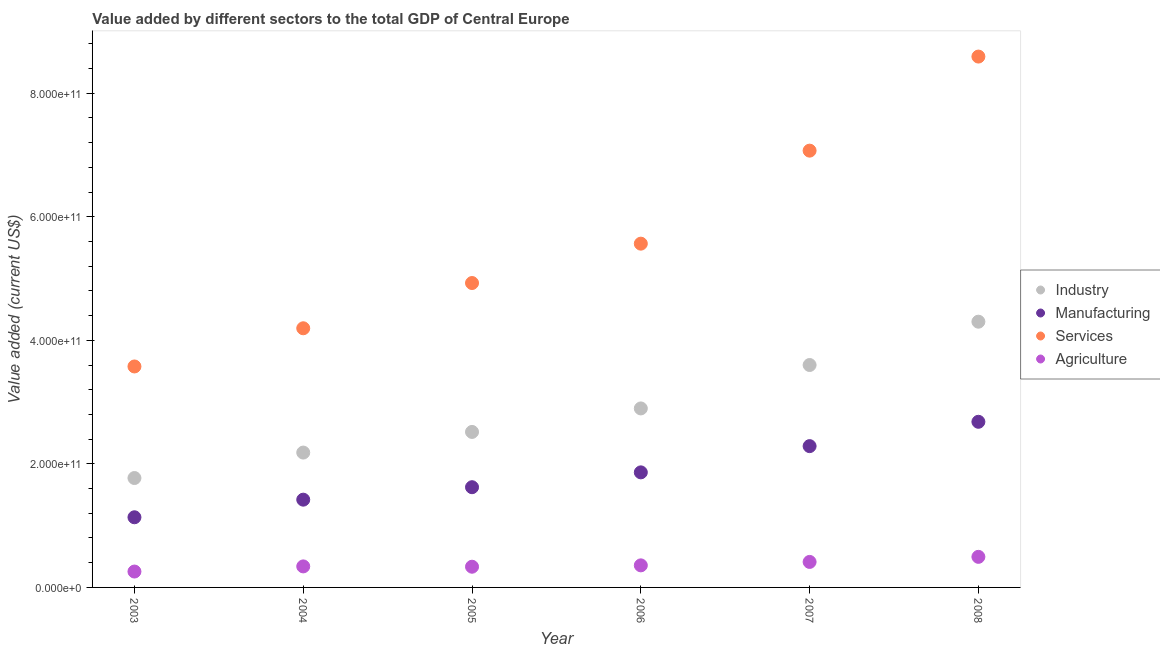What is the value added by manufacturing sector in 2005?
Ensure brevity in your answer.  1.62e+11. Across all years, what is the maximum value added by manufacturing sector?
Ensure brevity in your answer.  2.68e+11. Across all years, what is the minimum value added by manufacturing sector?
Give a very brief answer. 1.14e+11. In which year was the value added by manufacturing sector maximum?
Give a very brief answer. 2008. What is the total value added by manufacturing sector in the graph?
Provide a short and direct response. 1.10e+12. What is the difference between the value added by services sector in 2004 and that in 2006?
Provide a short and direct response. -1.37e+11. What is the difference between the value added by industrial sector in 2007 and the value added by services sector in 2008?
Keep it short and to the point. -4.99e+11. What is the average value added by agricultural sector per year?
Offer a very short reply. 3.66e+1. In the year 2006, what is the difference between the value added by manufacturing sector and value added by services sector?
Make the answer very short. -3.70e+11. What is the ratio of the value added by agricultural sector in 2006 to that in 2007?
Your response must be concise. 0.87. Is the value added by manufacturing sector in 2006 less than that in 2008?
Give a very brief answer. Yes. Is the difference between the value added by services sector in 2006 and 2008 greater than the difference between the value added by manufacturing sector in 2006 and 2008?
Your response must be concise. No. What is the difference between the highest and the second highest value added by industrial sector?
Make the answer very short. 7.01e+1. What is the difference between the highest and the lowest value added by agricultural sector?
Provide a short and direct response. 2.38e+1. Is it the case that in every year, the sum of the value added by industrial sector and value added by manufacturing sector is greater than the value added by services sector?
Ensure brevity in your answer.  No. Does the value added by services sector monotonically increase over the years?
Your answer should be very brief. Yes. Is the value added by industrial sector strictly greater than the value added by manufacturing sector over the years?
Your answer should be very brief. Yes. Is the value added by industrial sector strictly less than the value added by manufacturing sector over the years?
Provide a succinct answer. No. How many years are there in the graph?
Your answer should be compact. 6. What is the difference between two consecutive major ticks on the Y-axis?
Provide a short and direct response. 2.00e+11. Are the values on the major ticks of Y-axis written in scientific E-notation?
Make the answer very short. Yes. Does the graph contain any zero values?
Ensure brevity in your answer.  No. Does the graph contain grids?
Offer a very short reply. No. How are the legend labels stacked?
Your response must be concise. Vertical. What is the title of the graph?
Provide a succinct answer. Value added by different sectors to the total GDP of Central Europe. What is the label or title of the X-axis?
Keep it short and to the point. Year. What is the label or title of the Y-axis?
Your response must be concise. Value added (current US$). What is the Value added (current US$) of Industry in 2003?
Offer a very short reply. 1.77e+11. What is the Value added (current US$) in Manufacturing in 2003?
Your answer should be compact. 1.14e+11. What is the Value added (current US$) in Services in 2003?
Your answer should be very brief. 3.58e+11. What is the Value added (current US$) of Agriculture in 2003?
Ensure brevity in your answer.  2.57e+1. What is the Value added (current US$) in Industry in 2004?
Offer a very short reply. 2.18e+11. What is the Value added (current US$) in Manufacturing in 2004?
Provide a short and direct response. 1.42e+11. What is the Value added (current US$) of Services in 2004?
Your answer should be very brief. 4.19e+11. What is the Value added (current US$) of Agriculture in 2004?
Provide a succinct answer. 3.40e+1. What is the Value added (current US$) in Industry in 2005?
Give a very brief answer. 2.52e+11. What is the Value added (current US$) in Manufacturing in 2005?
Offer a terse response. 1.62e+11. What is the Value added (current US$) in Services in 2005?
Provide a succinct answer. 4.93e+11. What is the Value added (current US$) in Agriculture in 2005?
Your answer should be compact. 3.35e+1. What is the Value added (current US$) of Industry in 2006?
Make the answer very short. 2.90e+11. What is the Value added (current US$) in Manufacturing in 2006?
Keep it short and to the point. 1.86e+11. What is the Value added (current US$) in Services in 2006?
Offer a very short reply. 5.56e+11. What is the Value added (current US$) of Agriculture in 2006?
Provide a succinct answer. 3.57e+1. What is the Value added (current US$) of Industry in 2007?
Your answer should be compact. 3.60e+11. What is the Value added (current US$) of Manufacturing in 2007?
Offer a very short reply. 2.29e+11. What is the Value added (current US$) of Services in 2007?
Provide a succinct answer. 7.07e+11. What is the Value added (current US$) in Agriculture in 2007?
Offer a terse response. 4.13e+1. What is the Value added (current US$) in Industry in 2008?
Your answer should be compact. 4.30e+11. What is the Value added (current US$) of Manufacturing in 2008?
Make the answer very short. 2.68e+11. What is the Value added (current US$) in Services in 2008?
Your answer should be very brief. 8.59e+11. What is the Value added (current US$) of Agriculture in 2008?
Ensure brevity in your answer.  4.95e+1. Across all years, what is the maximum Value added (current US$) of Industry?
Your answer should be very brief. 4.30e+11. Across all years, what is the maximum Value added (current US$) in Manufacturing?
Make the answer very short. 2.68e+11. Across all years, what is the maximum Value added (current US$) of Services?
Offer a very short reply. 8.59e+11. Across all years, what is the maximum Value added (current US$) in Agriculture?
Ensure brevity in your answer.  4.95e+1. Across all years, what is the minimum Value added (current US$) in Industry?
Make the answer very short. 1.77e+11. Across all years, what is the minimum Value added (current US$) of Manufacturing?
Your answer should be very brief. 1.14e+11. Across all years, what is the minimum Value added (current US$) in Services?
Keep it short and to the point. 3.58e+11. Across all years, what is the minimum Value added (current US$) of Agriculture?
Your answer should be compact. 2.57e+1. What is the total Value added (current US$) in Industry in the graph?
Give a very brief answer. 1.73e+12. What is the total Value added (current US$) in Manufacturing in the graph?
Your response must be concise. 1.10e+12. What is the total Value added (current US$) of Services in the graph?
Offer a terse response. 3.39e+12. What is the total Value added (current US$) in Agriculture in the graph?
Provide a succinct answer. 2.20e+11. What is the difference between the Value added (current US$) in Industry in 2003 and that in 2004?
Your response must be concise. -4.12e+1. What is the difference between the Value added (current US$) of Manufacturing in 2003 and that in 2004?
Your answer should be very brief. -2.85e+1. What is the difference between the Value added (current US$) in Services in 2003 and that in 2004?
Provide a succinct answer. -6.18e+1. What is the difference between the Value added (current US$) of Agriculture in 2003 and that in 2004?
Provide a short and direct response. -8.32e+09. What is the difference between the Value added (current US$) in Industry in 2003 and that in 2005?
Your answer should be compact. -7.46e+1. What is the difference between the Value added (current US$) of Manufacturing in 2003 and that in 2005?
Offer a terse response. -4.87e+1. What is the difference between the Value added (current US$) in Services in 2003 and that in 2005?
Make the answer very short. -1.35e+11. What is the difference between the Value added (current US$) in Agriculture in 2003 and that in 2005?
Provide a succinct answer. -7.81e+09. What is the difference between the Value added (current US$) in Industry in 2003 and that in 2006?
Your answer should be compact. -1.13e+11. What is the difference between the Value added (current US$) of Manufacturing in 2003 and that in 2006?
Give a very brief answer. -7.27e+1. What is the difference between the Value added (current US$) of Services in 2003 and that in 2006?
Keep it short and to the point. -1.99e+11. What is the difference between the Value added (current US$) of Agriculture in 2003 and that in 2006?
Give a very brief answer. -1.00e+1. What is the difference between the Value added (current US$) in Industry in 2003 and that in 2007?
Make the answer very short. -1.83e+11. What is the difference between the Value added (current US$) of Manufacturing in 2003 and that in 2007?
Keep it short and to the point. -1.15e+11. What is the difference between the Value added (current US$) in Services in 2003 and that in 2007?
Offer a terse response. -3.49e+11. What is the difference between the Value added (current US$) in Agriculture in 2003 and that in 2007?
Keep it short and to the point. -1.56e+1. What is the difference between the Value added (current US$) of Industry in 2003 and that in 2008?
Keep it short and to the point. -2.53e+11. What is the difference between the Value added (current US$) of Manufacturing in 2003 and that in 2008?
Your answer should be compact. -1.55e+11. What is the difference between the Value added (current US$) in Services in 2003 and that in 2008?
Make the answer very short. -5.02e+11. What is the difference between the Value added (current US$) in Agriculture in 2003 and that in 2008?
Offer a terse response. -2.38e+1. What is the difference between the Value added (current US$) in Industry in 2004 and that in 2005?
Offer a terse response. -3.34e+1. What is the difference between the Value added (current US$) of Manufacturing in 2004 and that in 2005?
Make the answer very short. -2.02e+1. What is the difference between the Value added (current US$) of Services in 2004 and that in 2005?
Provide a short and direct response. -7.32e+1. What is the difference between the Value added (current US$) of Agriculture in 2004 and that in 2005?
Make the answer very short. 5.11e+08. What is the difference between the Value added (current US$) of Industry in 2004 and that in 2006?
Give a very brief answer. -7.15e+1. What is the difference between the Value added (current US$) of Manufacturing in 2004 and that in 2006?
Offer a terse response. -4.42e+1. What is the difference between the Value added (current US$) of Services in 2004 and that in 2006?
Offer a terse response. -1.37e+11. What is the difference between the Value added (current US$) of Agriculture in 2004 and that in 2006?
Give a very brief answer. -1.69e+09. What is the difference between the Value added (current US$) of Industry in 2004 and that in 2007?
Your answer should be compact. -1.42e+11. What is the difference between the Value added (current US$) in Manufacturing in 2004 and that in 2007?
Your answer should be compact. -8.67e+1. What is the difference between the Value added (current US$) of Services in 2004 and that in 2007?
Your answer should be compact. -2.88e+11. What is the difference between the Value added (current US$) in Agriculture in 2004 and that in 2007?
Your response must be concise. -7.26e+09. What is the difference between the Value added (current US$) of Industry in 2004 and that in 2008?
Provide a succinct answer. -2.12e+11. What is the difference between the Value added (current US$) of Manufacturing in 2004 and that in 2008?
Keep it short and to the point. -1.26e+11. What is the difference between the Value added (current US$) of Services in 2004 and that in 2008?
Provide a succinct answer. -4.40e+11. What is the difference between the Value added (current US$) of Agriculture in 2004 and that in 2008?
Ensure brevity in your answer.  -1.55e+1. What is the difference between the Value added (current US$) in Industry in 2005 and that in 2006?
Your response must be concise. -3.80e+1. What is the difference between the Value added (current US$) of Manufacturing in 2005 and that in 2006?
Ensure brevity in your answer.  -2.40e+1. What is the difference between the Value added (current US$) of Services in 2005 and that in 2006?
Make the answer very short. -6.37e+1. What is the difference between the Value added (current US$) of Agriculture in 2005 and that in 2006?
Keep it short and to the point. -2.20e+09. What is the difference between the Value added (current US$) in Industry in 2005 and that in 2007?
Your answer should be very brief. -1.08e+11. What is the difference between the Value added (current US$) in Manufacturing in 2005 and that in 2007?
Provide a short and direct response. -6.65e+1. What is the difference between the Value added (current US$) in Services in 2005 and that in 2007?
Your response must be concise. -2.14e+11. What is the difference between the Value added (current US$) of Agriculture in 2005 and that in 2007?
Your answer should be very brief. -7.77e+09. What is the difference between the Value added (current US$) of Industry in 2005 and that in 2008?
Your answer should be compact. -1.78e+11. What is the difference between the Value added (current US$) in Manufacturing in 2005 and that in 2008?
Offer a very short reply. -1.06e+11. What is the difference between the Value added (current US$) of Services in 2005 and that in 2008?
Your answer should be compact. -3.67e+11. What is the difference between the Value added (current US$) of Agriculture in 2005 and that in 2008?
Ensure brevity in your answer.  -1.60e+1. What is the difference between the Value added (current US$) of Industry in 2006 and that in 2007?
Your answer should be very brief. -7.03e+1. What is the difference between the Value added (current US$) of Manufacturing in 2006 and that in 2007?
Offer a very short reply. -4.25e+1. What is the difference between the Value added (current US$) of Services in 2006 and that in 2007?
Ensure brevity in your answer.  -1.51e+11. What is the difference between the Value added (current US$) of Agriculture in 2006 and that in 2007?
Ensure brevity in your answer.  -5.57e+09. What is the difference between the Value added (current US$) in Industry in 2006 and that in 2008?
Keep it short and to the point. -1.40e+11. What is the difference between the Value added (current US$) in Manufacturing in 2006 and that in 2008?
Ensure brevity in your answer.  -8.18e+1. What is the difference between the Value added (current US$) of Services in 2006 and that in 2008?
Offer a terse response. -3.03e+11. What is the difference between the Value added (current US$) of Agriculture in 2006 and that in 2008?
Provide a short and direct response. -1.38e+1. What is the difference between the Value added (current US$) of Industry in 2007 and that in 2008?
Provide a short and direct response. -7.01e+1. What is the difference between the Value added (current US$) in Manufacturing in 2007 and that in 2008?
Your answer should be compact. -3.94e+1. What is the difference between the Value added (current US$) of Services in 2007 and that in 2008?
Your answer should be very brief. -1.52e+11. What is the difference between the Value added (current US$) of Agriculture in 2007 and that in 2008?
Offer a very short reply. -8.21e+09. What is the difference between the Value added (current US$) of Industry in 2003 and the Value added (current US$) of Manufacturing in 2004?
Keep it short and to the point. 3.50e+1. What is the difference between the Value added (current US$) of Industry in 2003 and the Value added (current US$) of Services in 2004?
Provide a succinct answer. -2.42e+11. What is the difference between the Value added (current US$) in Industry in 2003 and the Value added (current US$) in Agriculture in 2004?
Your answer should be compact. 1.43e+11. What is the difference between the Value added (current US$) in Manufacturing in 2003 and the Value added (current US$) in Services in 2004?
Ensure brevity in your answer.  -3.06e+11. What is the difference between the Value added (current US$) of Manufacturing in 2003 and the Value added (current US$) of Agriculture in 2004?
Provide a succinct answer. 7.95e+1. What is the difference between the Value added (current US$) in Services in 2003 and the Value added (current US$) in Agriculture in 2004?
Give a very brief answer. 3.24e+11. What is the difference between the Value added (current US$) of Industry in 2003 and the Value added (current US$) of Manufacturing in 2005?
Your answer should be very brief. 1.49e+1. What is the difference between the Value added (current US$) in Industry in 2003 and the Value added (current US$) in Services in 2005?
Your answer should be compact. -3.16e+11. What is the difference between the Value added (current US$) in Industry in 2003 and the Value added (current US$) in Agriculture in 2005?
Give a very brief answer. 1.44e+11. What is the difference between the Value added (current US$) in Manufacturing in 2003 and the Value added (current US$) in Services in 2005?
Provide a short and direct response. -3.79e+11. What is the difference between the Value added (current US$) in Manufacturing in 2003 and the Value added (current US$) in Agriculture in 2005?
Make the answer very short. 8.00e+1. What is the difference between the Value added (current US$) in Services in 2003 and the Value added (current US$) in Agriculture in 2005?
Provide a short and direct response. 3.24e+11. What is the difference between the Value added (current US$) in Industry in 2003 and the Value added (current US$) in Manufacturing in 2006?
Your answer should be compact. -9.16e+09. What is the difference between the Value added (current US$) in Industry in 2003 and the Value added (current US$) in Services in 2006?
Your response must be concise. -3.79e+11. What is the difference between the Value added (current US$) in Industry in 2003 and the Value added (current US$) in Agriculture in 2006?
Keep it short and to the point. 1.41e+11. What is the difference between the Value added (current US$) in Manufacturing in 2003 and the Value added (current US$) in Services in 2006?
Your response must be concise. -4.43e+11. What is the difference between the Value added (current US$) in Manufacturing in 2003 and the Value added (current US$) in Agriculture in 2006?
Keep it short and to the point. 7.78e+1. What is the difference between the Value added (current US$) in Services in 2003 and the Value added (current US$) in Agriculture in 2006?
Make the answer very short. 3.22e+11. What is the difference between the Value added (current US$) in Industry in 2003 and the Value added (current US$) in Manufacturing in 2007?
Your response must be concise. -5.16e+1. What is the difference between the Value added (current US$) in Industry in 2003 and the Value added (current US$) in Services in 2007?
Make the answer very short. -5.30e+11. What is the difference between the Value added (current US$) of Industry in 2003 and the Value added (current US$) of Agriculture in 2007?
Ensure brevity in your answer.  1.36e+11. What is the difference between the Value added (current US$) in Manufacturing in 2003 and the Value added (current US$) in Services in 2007?
Make the answer very short. -5.93e+11. What is the difference between the Value added (current US$) in Manufacturing in 2003 and the Value added (current US$) in Agriculture in 2007?
Your answer should be very brief. 7.23e+1. What is the difference between the Value added (current US$) of Services in 2003 and the Value added (current US$) of Agriculture in 2007?
Provide a short and direct response. 3.16e+11. What is the difference between the Value added (current US$) of Industry in 2003 and the Value added (current US$) of Manufacturing in 2008?
Your answer should be very brief. -9.10e+1. What is the difference between the Value added (current US$) in Industry in 2003 and the Value added (current US$) in Services in 2008?
Provide a short and direct response. -6.82e+11. What is the difference between the Value added (current US$) of Industry in 2003 and the Value added (current US$) of Agriculture in 2008?
Make the answer very short. 1.28e+11. What is the difference between the Value added (current US$) in Manufacturing in 2003 and the Value added (current US$) in Services in 2008?
Keep it short and to the point. -7.46e+11. What is the difference between the Value added (current US$) of Manufacturing in 2003 and the Value added (current US$) of Agriculture in 2008?
Ensure brevity in your answer.  6.41e+1. What is the difference between the Value added (current US$) of Services in 2003 and the Value added (current US$) of Agriculture in 2008?
Keep it short and to the point. 3.08e+11. What is the difference between the Value added (current US$) of Industry in 2004 and the Value added (current US$) of Manufacturing in 2005?
Make the answer very short. 5.60e+1. What is the difference between the Value added (current US$) of Industry in 2004 and the Value added (current US$) of Services in 2005?
Your response must be concise. -2.74e+11. What is the difference between the Value added (current US$) in Industry in 2004 and the Value added (current US$) in Agriculture in 2005?
Your answer should be very brief. 1.85e+11. What is the difference between the Value added (current US$) of Manufacturing in 2004 and the Value added (current US$) of Services in 2005?
Your answer should be very brief. -3.51e+11. What is the difference between the Value added (current US$) of Manufacturing in 2004 and the Value added (current US$) of Agriculture in 2005?
Your response must be concise. 1.09e+11. What is the difference between the Value added (current US$) of Services in 2004 and the Value added (current US$) of Agriculture in 2005?
Ensure brevity in your answer.  3.86e+11. What is the difference between the Value added (current US$) in Industry in 2004 and the Value added (current US$) in Manufacturing in 2006?
Offer a terse response. 3.20e+1. What is the difference between the Value added (current US$) in Industry in 2004 and the Value added (current US$) in Services in 2006?
Offer a very short reply. -3.38e+11. What is the difference between the Value added (current US$) in Industry in 2004 and the Value added (current US$) in Agriculture in 2006?
Your answer should be compact. 1.83e+11. What is the difference between the Value added (current US$) of Manufacturing in 2004 and the Value added (current US$) of Services in 2006?
Your answer should be very brief. -4.14e+11. What is the difference between the Value added (current US$) in Manufacturing in 2004 and the Value added (current US$) in Agriculture in 2006?
Keep it short and to the point. 1.06e+11. What is the difference between the Value added (current US$) of Services in 2004 and the Value added (current US$) of Agriculture in 2006?
Keep it short and to the point. 3.84e+11. What is the difference between the Value added (current US$) in Industry in 2004 and the Value added (current US$) in Manufacturing in 2007?
Provide a short and direct response. -1.04e+1. What is the difference between the Value added (current US$) in Industry in 2004 and the Value added (current US$) in Services in 2007?
Give a very brief answer. -4.89e+11. What is the difference between the Value added (current US$) of Industry in 2004 and the Value added (current US$) of Agriculture in 2007?
Offer a terse response. 1.77e+11. What is the difference between the Value added (current US$) of Manufacturing in 2004 and the Value added (current US$) of Services in 2007?
Your answer should be very brief. -5.65e+11. What is the difference between the Value added (current US$) in Manufacturing in 2004 and the Value added (current US$) in Agriculture in 2007?
Give a very brief answer. 1.01e+11. What is the difference between the Value added (current US$) of Services in 2004 and the Value added (current US$) of Agriculture in 2007?
Keep it short and to the point. 3.78e+11. What is the difference between the Value added (current US$) of Industry in 2004 and the Value added (current US$) of Manufacturing in 2008?
Offer a terse response. -4.98e+1. What is the difference between the Value added (current US$) in Industry in 2004 and the Value added (current US$) in Services in 2008?
Offer a very short reply. -6.41e+11. What is the difference between the Value added (current US$) of Industry in 2004 and the Value added (current US$) of Agriculture in 2008?
Your answer should be compact. 1.69e+11. What is the difference between the Value added (current US$) in Manufacturing in 2004 and the Value added (current US$) in Services in 2008?
Ensure brevity in your answer.  -7.17e+11. What is the difference between the Value added (current US$) of Manufacturing in 2004 and the Value added (current US$) of Agriculture in 2008?
Offer a terse response. 9.26e+1. What is the difference between the Value added (current US$) of Services in 2004 and the Value added (current US$) of Agriculture in 2008?
Offer a very short reply. 3.70e+11. What is the difference between the Value added (current US$) of Industry in 2005 and the Value added (current US$) of Manufacturing in 2006?
Your answer should be very brief. 6.54e+1. What is the difference between the Value added (current US$) in Industry in 2005 and the Value added (current US$) in Services in 2006?
Ensure brevity in your answer.  -3.05e+11. What is the difference between the Value added (current US$) in Industry in 2005 and the Value added (current US$) in Agriculture in 2006?
Make the answer very short. 2.16e+11. What is the difference between the Value added (current US$) of Manufacturing in 2005 and the Value added (current US$) of Services in 2006?
Keep it short and to the point. -3.94e+11. What is the difference between the Value added (current US$) of Manufacturing in 2005 and the Value added (current US$) of Agriculture in 2006?
Provide a short and direct response. 1.27e+11. What is the difference between the Value added (current US$) of Services in 2005 and the Value added (current US$) of Agriculture in 2006?
Provide a succinct answer. 4.57e+11. What is the difference between the Value added (current US$) of Industry in 2005 and the Value added (current US$) of Manufacturing in 2007?
Provide a short and direct response. 2.30e+1. What is the difference between the Value added (current US$) of Industry in 2005 and the Value added (current US$) of Services in 2007?
Your answer should be very brief. -4.55e+11. What is the difference between the Value added (current US$) in Industry in 2005 and the Value added (current US$) in Agriculture in 2007?
Keep it short and to the point. 2.10e+11. What is the difference between the Value added (current US$) of Manufacturing in 2005 and the Value added (current US$) of Services in 2007?
Ensure brevity in your answer.  -5.45e+11. What is the difference between the Value added (current US$) in Manufacturing in 2005 and the Value added (current US$) in Agriculture in 2007?
Provide a short and direct response. 1.21e+11. What is the difference between the Value added (current US$) in Services in 2005 and the Value added (current US$) in Agriculture in 2007?
Provide a succinct answer. 4.51e+11. What is the difference between the Value added (current US$) in Industry in 2005 and the Value added (current US$) in Manufacturing in 2008?
Provide a succinct answer. -1.64e+1. What is the difference between the Value added (current US$) of Industry in 2005 and the Value added (current US$) of Services in 2008?
Ensure brevity in your answer.  -6.08e+11. What is the difference between the Value added (current US$) of Industry in 2005 and the Value added (current US$) of Agriculture in 2008?
Ensure brevity in your answer.  2.02e+11. What is the difference between the Value added (current US$) of Manufacturing in 2005 and the Value added (current US$) of Services in 2008?
Your answer should be very brief. -6.97e+11. What is the difference between the Value added (current US$) in Manufacturing in 2005 and the Value added (current US$) in Agriculture in 2008?
Offer a terse response. 1.13e+11. What is the difference between the Value added (current US$) of Services in 2005 and the Value added (current US$) of Agriculture in 2008?
Keep it short and to the point. 4.43e+11. What is the difference between the Value added (current US$) in Industry in 2006 and the Value added (current US$) in Manufacturing in 2007?
Make the answer very short. 6.10e+1. What is the difference between the Value added (current US$) in Industry in 2006 and the Value added (current US$) in Services in 2007?
Your response must be concise. -4.17e+11. What is the difference between the Value added (current US$) of Industry in 2006 and the Value added (current US$) of Agriculture in 2007?
Provide a succinct answer. 2.48e+11. What is the difference between the Value added (current US$) of Manufacturing in 2006 and the Value added (current US$) of Services in 2007?
Offer a terse response. -5.21e+11. What is the difference between the Value added (current US$) in Manufacturing in 2006 and the Value added (current US$) in Agriculture in 2007?
Give a very brief answer. 1.45e+11. What is the difference between the Value added (current US$) in Services in 2006 and the Value added (current US$) in Agriculture in 2007?
Your response must be concise. 5.15e+11. What is the difference between the Value added (current US$) of Industry in 2006 and the Value added (current US$) of Manufacturing in 2008?
Provide a short and direct response. 2.16e+1. What is the difference between the Value added (current US$) in Industry in 2006 and the Value added (current US$) in Services in 2008?
Offer a very short reply. -5.69e+11. What is the difference between the Value added (current US$) in Industry in 2006 and the Value added (current US$) in Agriculture in 2008?
Keep it short and to the point. 2.40e+11. What is the difference between the Value added (current US$) in Manufacturing in 2006 and the Value added (current US$) in Services in 2008?
Keep it short and to the point. -6.73e+11. What is the difference between the Value added (current US$) in Manufacturing in 2006 and the Value added (current US$) in Agriculture in 2008?
Your answer should be compact. 1.37e+11. What is the difference between the Value added (current US$) of Services in 2006 and the Value added (current US$) of Agriculture in 2008?
Keep it short and to the point. 5.07e+11. What is the difference between the Value added (current US$) of Industry in 2007 and the Value added (current US$) of Manufacturing in 2008?
Your answer should be compact. 9.19e+1. What is the difference between the Value added (current US$) in Industry in 2007 and the Value added (current US$) in Services in 2008?
Your answer should be compact. -4.99e+11. What is the difference between the Value added (current US$) of Industry in 2007 and the Value added (current US$) of Agriculture in 2008?
Provide a succinct answer. 3.11e+11. What is the difference between the Value added (current US$) of Manufacturing in 2007 and the Value added (current US$) of Services in 2008?
Ensure brevity in your answer.  -6.31e+11. What is the difference between the Value added (current US$) in Manufacturing in 2007 and the Value added (current US$) in Agriculture in 2008?
Make the answer very short. 1.79e+11. What is the difference between the Value added (current US$) in Services in 2007 and the Value added (current US$) in Agriculture in 2008?
Make the answer very short. 6.57e+11. What is the average Value added (current US$) of Industry per year?
Offer a very short reply. 2.88e+11. What is the average Value added (current US$) in Manufacturing per year?
Offer a very short reply. 1.83e+11. What is the average Value added (current US$) of Services per year?
Offer a terse response. 5.65e+11. What is the average Value added (current US$) in Agriculture per year?
Your answer should be very brief. 3.66e+1. In the year 2003, what is the difference between the Value added (current US$) in Industry and Value added (current US$) in Manufacturing?
Your answer should be compact. 6.35e+1. In the year 2003, what is the difference between the Value added (current US$) in Industry and Value added (current US$) in Services?
Your answer should be compact. -1.81e+11. In the year 2003, what is the difference between the Value added (current US$) of Industry and Value added (current US$) of Agriculture?
Ensure brevity in your answer.  1.51e+11. In the year 2003, what is the difference between the Value added (current US$) in Manufacturing and Value added (current US$) in Services?
Provide a short and direct response. -2.44e+11. In the year 2003, what is the difference between the Value added (current US$) in Manufacturing and Value added (current US$) in Agriculture?
Give a very brief answer. 8.78e+1. In the year 2003, what is the difference between the Value added (current US$) in Services and Value added (current US$) in Agriculture?
Offer a very short reply. 3.32e+11. In the year 2004, what is the difference between the Value added (current US$) in Industry and Value added (current US$) in Manufacturing?
Give a very brief answer. 7.62e+1. In the year 2004, what is the difference between the Value added (current US$) of Industry and Value added (current US$) of Services?
Ensure brevity in your answer.  -2.01e+11. In the year 2004, what is the difference between the Value added (current US$) of Industry and Value added (current US$) of Agriculture?
Provide a short and direct response. 1.84e+11. In the year 2004, what is the difference between the Value added (current US$) in Manufacturing and Value added (current US$) in Services?
Offer a terse response. -2.77e+11. In the year 2004, what is the difference between the Value added (current US$) of Manufacturing and Value added (current US$) of Agriculture?
Offer a terse response. 1.08e+11. In the year 2004, what is the difference between the Value added (current US$) in Services and Value added (current US$) in Agriculture?
Your response must be concise. 3.85e+11. In the year 2005, what is the difference between the Value added (current US$) in Industry and Value added (current US$) in Manufacturing?
Ensure brevity in your answer.  8.95e+1. In the year 2005, what is the difference between the Value added (current US$) of Industry and Value added (current US$) of Services?
Your answer should be very brief. -2.41e+11. In the year 2005, what is the difference between the Value added (current US$) in Industry and Value added (current US$) in Agriculture?
Offer a very short reply. 2.18e+11. In the year 2005, what is the difference between the Value added (current US$) in Manufacturing and Value added (current US$) in Services?
Your answer should be compact. -3.30e+11. In the year 2005, what is the difference between the Value added (current US$) in Manufacturing and Value added (current US$) in Agriculture?
Your response must be concise. 1.29e+11. In the year 2005, what is the difference between the Value added (current US$) in Services and Value added (current US$) in Agriculture?
Ensure brevity in your answer.  4.59e+11. In the year 2006, what is the difference between the Value added (current US$) of Industry and Value added (current US$) of Manufacturing?
Provide a succinct answer. 1.03e+11. In the year 2006, what is the difference between the Value added (current US$) of Industry and Value added (current US$) of Services?
Keep it short and to the point. -2.67e+11. In the year 2006, what is the difference between the Value added (current US$) of Industry and Value added (current US$) of Agriculture?
Make the answer very short. 2.54e+11. In the year 2006, what is the difference between the Value added (current US$) of Manufacturing and Value added (current US$) of Services?
Give a very brief answer. -3.70e+11. In the year 2006, what is the difference between the Value added (current US$) in Manufacturing and Value added (current US$) in Agriculture?
Your answer should be very brief. 1.51e+11. In the year 2006, what is the difference between the Value added (current US$) in Services and Value added (current US$) in Agriculture?
Offer a very short reply. 5.21e+11. In the year 2007, what is the difference between the Value added (current US$) in Industry and Value added (current US$) in Manufacturing?
Keep it short and to the point. 1.31e+11. In the year 2007, what is the difference between the Value added (current US$) of Industry and Value added (current US$) of Services?
Give a very brief answer. -3.47e+11. In the year 2007, what is the difference between the Value added (current US$) of Industry and Value added (current US$) of Agriculture?
Make the answer very short. 3.19e+11. In the year 2007, what is the difference between the Value added (current US$) of Manufacturing and Value added (current US$) of Services?
Ensure brevity in your answer.  -4.78e+11. In the year 2007, what is the difference between the Value added (current US$) of Manufacturing and Value added (current US$) of Agriculture?
Your answer should be compact. 1.87e+11. In the year 2007, what is the difference between the Value added (current US$) of Services and Value added (current US$) of Agriculture?
Ensure brevity in your answer.  6.66e+11. In the year 2008, what is the difference between the Value added (current US$) in Industry and Value added (current US$) in Manufacturing?
Provide a succinct answer. 1.62e+11. In the year 2008, what is the difference between the Value added (current US$) in Industry and Value added (current US$) in Services?
Your answer should be very brief. -4.29e+11. In the year 2008, what is the difference between the Value added (current US$) of Industry and Value added (current US$) of Agriculture?
Give a very brief answer. 3.81e+11. In the year 2008, what is the difference between the Value added (current US$) of Manufacturing and Value added (current US$) of Services?
Make the answer very short. -5.91e+11. In the year 2008, what is the difference between the Value added (current US$) of Manufacturing and Value added (current US$) of Agriculture?
Offer a very short reply. 2.19e+11. In the year 2008, what is the difference between the Value added (current US$) in Services and Value added (current US$) in Agriculture?
Provide a short and direct response. 8.10e+11. What is the ratio of the Value added (current US$) of Industry in 2003 to that in 2004?
Provide a short and direct response. 0.81. What is the ratio of the Value added (current US$) in Manufacturing in 2003 to that in 2004?
Offer a very short reply. 0.8. What is the ratio of the Value added (current US$) in Services in 2003 to that in 2004?
Provide a succinct answer. 0.85. What is the ratio of the Value added (current US$) of Agriculture in 2003 to that in 2004?
Offer a very short reply. 0.76. What is the ratio of the Value added (current US$) in Industry in 2003 to that in 2005?
Keep it short and to the point. 0.7. What is the ratio of the Value added (current US$) of Manufacturing in 2003 to that in 2005?
Your answer should be very brief. 0.7. What is the ratio of the Value added (current US$) in Services in 2003 to that in 2005?
Provide a succinct answer. 0.73. What is the ratio of the Value added (current US$) in Agriculture in 2003 to that in 2005?
Make the answer very short. 0.77. What is the ratio of the Value added (current US$) in Industry in 2003 to that in 2006?
Provide a short and direct response. 0.61. What is the ratio of the Value added (current US$) of Manufacturing in 2003 to that in 2006?
Provide a short and direct response. 0.61. What is the ratio of the Value added (current US$) of Services in 2003 to that in 2006?
Give a very brief answer. 0.64. What is the ratio of the Value added (current US$) of Agriculture in 2003 to that in 2006?
Make the answer very short. 0.72. What is the ratio of the Value added (current US$) in Industry in 2003 to that in 2007?
Keep it short and to the point. 0.49. What is the ratio of the Value added (current US$) in Manufacturing in 2003 to that in 2007?
Your response must be concise. 0.5. What is the ratio of the Value added (current US$) of Services in 2003 to that in 2007?
Offer a terse response. 0.51. What is the ratio of the Value added (current US$) in Agriculture in 2003 to that in 2007?
Provide a short and direct response. 0.62. What is the ratio of the Value added (current US$) of Industry in 2003 to that in 2008?
Give a very brief answer. 0.41. What is the ratio of the Value added (current US$) of Manufacturing in 2003 to that in 2008?
Keep it short and to the point. 0.42. What is the ratio of the Value added (current US$) in Services in 2003 to that in 2008?
Offer a terse response. 0.42. What is the ratio of the Value added (current US$) in Agriculture in 2003 to that in 2008?
Provide a succinct answer. 0.52. What is the ratio of the Value added (current US$) of Industry in 2004 to that in 2005?
Offer a very short reply. 0.87. What is the ratio of the Value added (current US$) of Manufacturing in 2004 to that in 2005?
Provide a succinct answer. 0.88. What is the ratio of the Value added (current US$) in Services in 2004 to that in 2005?
Your answer should be very brief. 0.85. What is the ratio of the Value added (current US$) of Agriculture in 2004 to that in 2005?
Your answer should be compact. 1.02. What is the ratio of the Value added (current US$) in Industry in 2004 to that in 2006?
Provide a succinct answer. 0.75. What is the ratio of the Value added (current US$) of Manufacturing in 2004 to that in 2006?
Make the answer very short. 0.76. What is the ratio of the Value added (current US$) of Services in 2004 to that in 2006?
Offer a terse response. 0.75. What is the ratio of the Value added (current US$) of Agriculture in 2004 to that in 2006?
Offer a very short reply. 0.95. What is the ratio of the Value added (current US$) in Industry in 2004 to that in 2007?
Ensure brevity in your answer.  0.61. What is the ratio of the Value added (current US$) of Manufacturing in 2004 to that in 2007?
Keep it short and to the point. 0.62. What is the ratio of the Value added (current US$) in Services in 2004 to that in 2007?
Provide a succinct answer. 0.59. What is the ratio of the Value added (current US$) of Agriculture in 2004 to that in 2007?
Provide a short and direct response. 0.82. What is the ratio of the Value added (current US$) of Industry in 2004 to that in 2008?
Provide a short and direct response. 0.51. What is the ratio of the Value added (current US$) in Manufacturing in 2004 to that in 2008?
Your answer should be compact. 0.53. What is the ratio of the Value added (current US$) in Services in 2004 to that in 2008?
Provide a short and direct response. 0.49. What is the ratio of the Value added (current US$) of Agriculture in 2004 to that in 2008?
Make the answer very short. 0.69. What is the ratio of the Value added (current US$) in Industry in 2005 to that in 2006?
Your answer should be compact. 0.87. What is the ratio of the Value added (current US$) in Manufacturing in 2005 to that in 2006?
Your answer should be very brief. 0.87. What is the ratio of the Value added (current US$) of Services in 2005 to that in 2006?
Your answer should be compact. 0.89. What is the ratio of the Value added (current US$) in Agriculture in 2005 to that in 2006?
Ensure brevity in your answer.  0.94. What is the ratio of the Value added (current US$) of Industry in 2005 to that in 2007?
Provide a succinct answer. 0.7. What is the ratio of the Value added (current US$) of Manufacturing in 2005 to that in 2007?
Offer a very short reply. 0.71. What is the ratio of the Value added (current US$) in Services in 2005 to that in 2007?
Provide a short and direct response. 0.7. What is the ratio of the Value added (current US$) in Agriculture in 2005 to that in 2007?
Provide a short and direct response. 0.81. What is the ratio of the Value added (current US$) in Industry in 2005 to that in 2008?
Your response must be concise. 0.59. What is the ratio of the Value added (current US$) in Manufacturing in 2005 to that in 2008?
Provide a succinct answer. 0.61. What is the ratio of the Value added (current US$) of Services in 2005 to that in 2008?
Give a very brief answer. 0.57. What is the ratio of the Value added (current US$) of Agriculture in 2005 to that in 2008?
Give a very brief answer. 0.68. What is the ratio of the Value added (current US$) of Industry in 2006 to that in 2007?
Give a very brief answer. 0.8. What is the ratio of the Value added (current US$) of Manufacturing in 2006 to that in 2007?
Ensure brevity in your answer.  0.81. What is the ratio of the Value added (current US$) of Services in 2006 to that in 2007?
Your response must be concise. 0.79. What is the ratio of the Value added (current US$) of Agriculture in 2006 to that in 2007?
Give a very brief answer. 0.86. What is the ratio of the Value added (current US$) in Industry in 2006 to that in 2008?
Make the answer very short. 0.67. What is the ratio of the Value added (current US$) in Manufacturing in 2006 to that in 2008?
Keep it short and to the point. 0.69. What is the ratio of the Value added (current US$) in Services in 2006 to that in 2008?
Keep it short and to the point. 0.65. What is the ratio of the Value added (current US$) of Agriculture in 2006 to that in 2008?
Provide a succinct answer. 0.72. What is the ratio of the Value added (current US$) of Industry in 2007 to that in 2008?
Provide a short and direct response. 0.84. What is the ratio of the Value added (current US$) of Manufacturing in 2007 to that in 2008?
Offer a terse response. 0.85. What is the ratio of the Value added (current US$) in Services in 2007 to that in 2008?
Provide a short and direct response. 0.82. What is the ratio of the Value added (current US$) in Agriculture in 2007 to that in 2008?
Keep it short and to the point. 0.83. What is the difference between the highest and the second highest Value added (current US$) in Industry?
Ensure brevity in your answer.  7.01e+1. What is the difference between the highest and the second highest Value added (current US$) in Manufacturing?
Provide a short and direct response. 3.94e+1. What is the difference between the highest and the second highest Value added (current US$) in Services?
Your answer should be compact. 1.52e+11. What is the difference between the highest and the second highest Value added (current US$) in Agriculture?
Your response must be concise. 8.21e+09. What is the difference between the highest and the lowest Value added (current US$) of Industry?
Make the answer very short. 2.53e+11. What is the difference between the highest and the lowest Value added (current US$) of Manufacturing?
Offer a very short reply. 1.55e+11. What is the difference between the highest and the lowest Value added (current US$) in Services?
Offer a very short reply. 5.02e+11. What is the difference between the highest and the lowest Value added (current US$) in Agriculture?
Make the answer very short. 2.38e+1. 